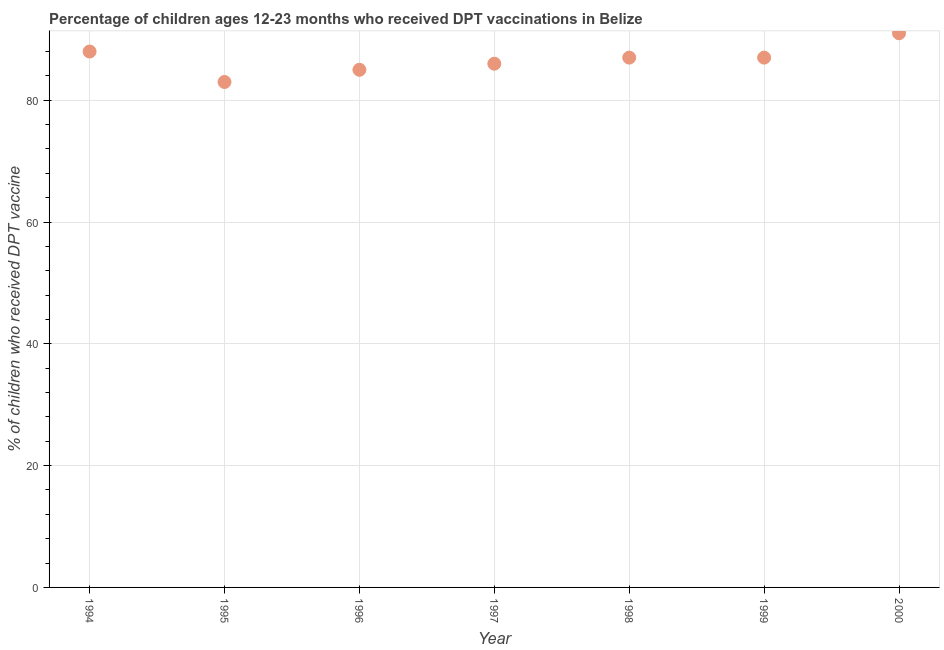What is the percentage of children who received dpt vaccine in 1997?
Provide a short and direct response. 86. Across all years, what is the maximum percentage of children who received dpt vaccine?
Your answer should be compact. 91. Across all years, what is the minimum percentage of children who received dpt vaccine?
Offer a very short reply. 83. In which year was the percentage of children who received dpt vaccine maximum?
Offer a terse response. 2000. In which year was the percentage of children who received dpt vaccine minimum?
Give a very brief answer. 1995. What is the sum of the percentage of children who received dpt vaccine?
Your answer should be very brief. 607. What is the difference between the percentage of children who received dpt vaccine in 1997 and 1999?
Your answer should be very brief. -1. What is the average percentage of children who received dpt vaccine per year?
Provide a short and direct response. 86.71. What is the median percentage of children who received dpt vaccine?
Your answer should be very brief. 87. What is the ratio of the percentage of children who received dpt vaccine in 1997 to that in 1999?
Make the answer very short. 0.99. Is the difference between the percentage of children who received dpt vaccine in 1999 and 2000 greater than the difference between any two years?
Provide a succinct answer. No. What is the difference between the highest and the lowest percentage of children who received dpt vaccine?
Keep it short and to the point. 8. Does the percentage of children who received dpt vaccine monotonically increase over the years?
Your response must be concise. No. What is the difference between two consecutive major ticks on the Y-axis?
Make the answer very short. 20. Are the values on the major ticks of Y-axis written in scientific E-notation?
Give a very brief answer. No. Does the graph contain grids?
Offer a very short reply. Yes. What is the title of the graph?
Your response must be concise. Percentage of children ages 12-23 months who received DPT vaccinations in Belize. What is the label or title of the Y-axis?
Offer a very short reply. % of children who received DPT vaccine. What is the % of children who received DPT vaccine in 1999?
Make the answer very short. 87. What is the % of children who received DPT vaccine in 2000?
Give a very brief answer. 91. What is the difference between the % of children who received DPT vaccine in 1994 and 1997?
Your answer should be compact. 2. What is the difference between the % of children who received DPT vaccine in 1994 and 1998?
Your answer should be compact. 1. What is the difference between the % of children who received DPT vaccine in 1995 and 1997?
Offer a very short reply. -3. What is the difference between the % of children who received DPT vaccine in 1995 and 1998?
Make the answer very short. -4. What is the difference between the % of children who received DPT vaccine in 1996 and 1999?
Give a very brief answer. -2. What is the difference between the % of children who received DPT vaccine in 1998 and 1999?
Provide a short and direct response. 0. What is the ratio of the % of children who received DPT vaccine in 1994 to that in 1995?
Ensure brevity in your answer.  1.06. What is the ratio of the % of children who received DPT vaccine in 1994 to that in 1996?
Provide a succinct answer. 1.03. What is the ratio of the % of children who received DPT vaccine in 1994 to that in 1999?
Your answer should be very brief. 1.01. What is the ratio of the % of children who received DPT vaccine in 1995 to that in 1996?
Your response must be concise. 0.98. What is the ratio of the % of children who received DPT vaccine in 1995 to that in 1997?
Offer a very short reply. 0.96. What is the ratio of the % of children who received DPT vaccine in 1995 to that in 1998?
Offer a terse response. 0.95. What is the ratio of the % of children who received DPT vaccine in 1995 to that in 1999?
Provide a short and direct response. 0.95. What is the ratio of the % of children who received DPT vaccine in 1995 to that in 2000?
Give a very brief answer. 0.91. What is the ratio of the % of children who received DPT vaccine in 1996 to that in 1997?
Provide a short and direct response. 0.99. What is the ratio of the % of children who received DPT vaccine in 1996 to that in 1998?
Your response must be concise. 0.98. What is the ratio of the % of children who received DPT vaccine in 1996 to that in 1999?
Your response must be concise. 0.98. What is the ratio of the % of children who received DPT vaccine in 1996 to that in 2000?
Ensure brevity in your answer.  0.93. What is the ratio of the % of children who received DPT vaccine in 1997 to that in 2000?
Provide a short and direct response. 0.94. What is the ratio of the % of children who received DPT vaccine in 1998 to that in 2000?
Offer a terse response. 0.96. What is the ratio of the % of children who received DPT vaccine in 1999 to that in 2000?
Your answer should be compact. 0.96. 